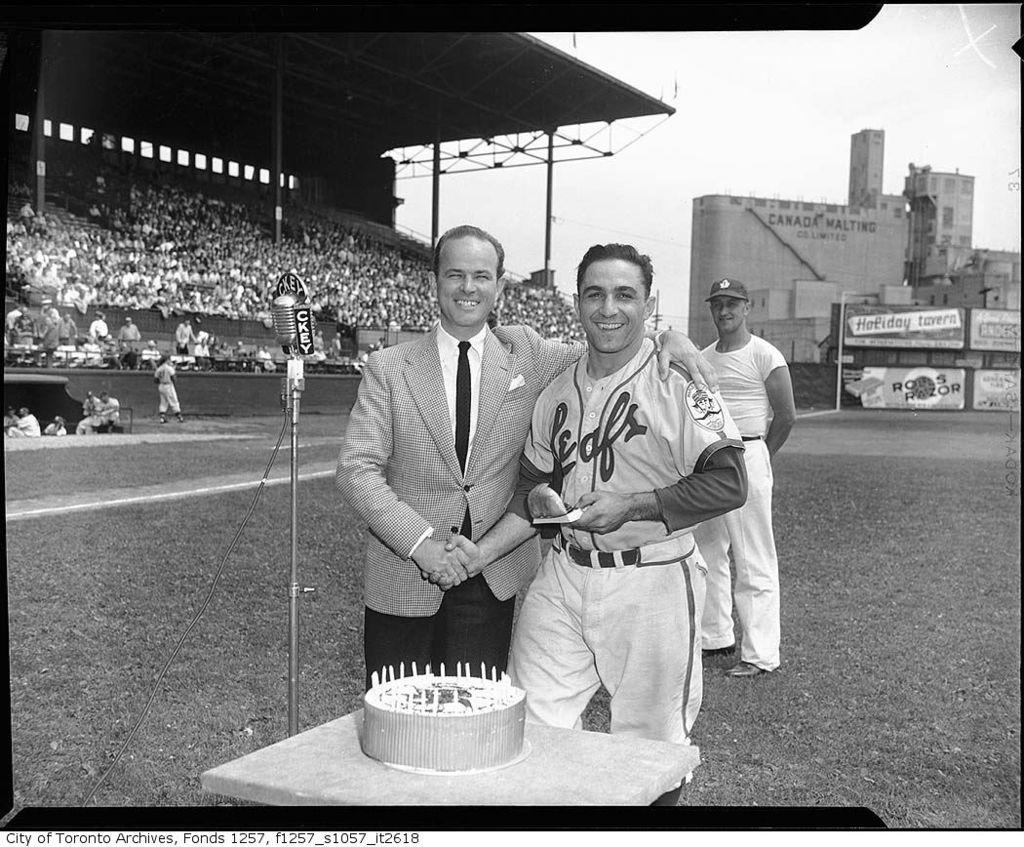<image>
Offer a succinct explanation of the picture presented. The player in the jersey is plating for the Leafs 